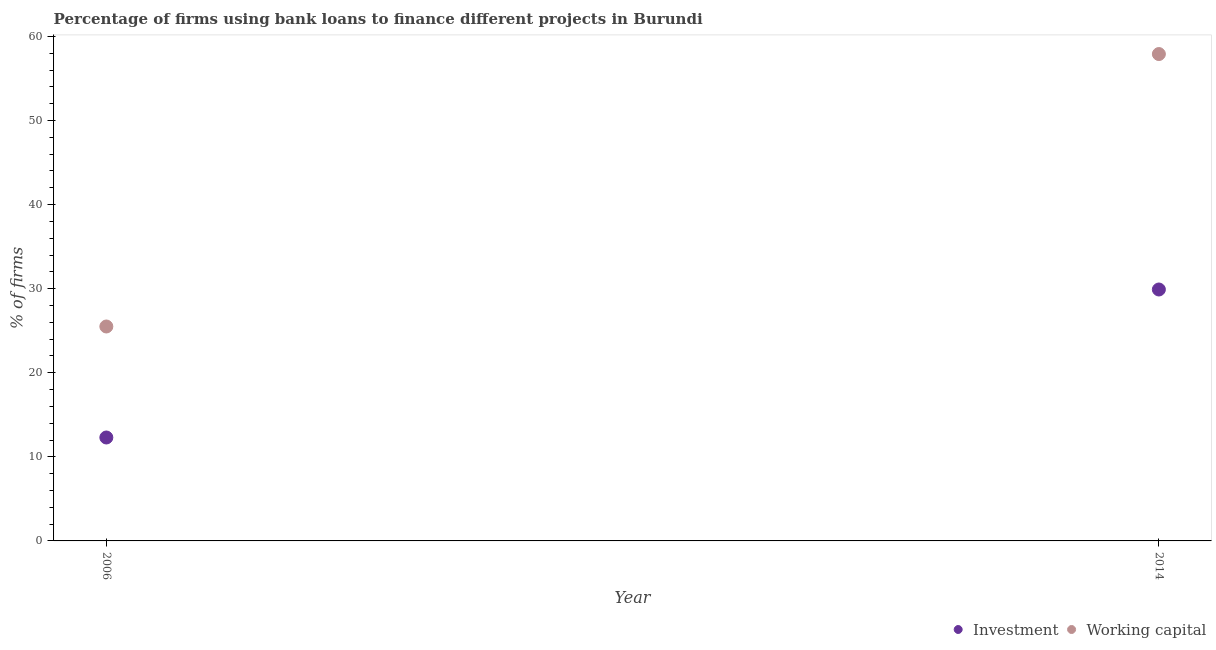How many different coloured dotlines are there?
Provide a succinct answer. 2. Across all years, what is the maximum percentage of firms using banks to finance investment?
Your answer should be very brief. 29.9. Across all years, what is the minimum percentage of firms using banks to finance investment?
Offer a very short reply. 12.3. In which year was the percentage of firms using banks to finance investment maximum?
Your answer should be compact. 2014. In which year was the percentage of firms using banks to finance working capital minimum?
Your answer should be very brief. 2006. What is the total percentage of firms using banks to finance investment in the graph?
Give a very brief answer. 42.2. What is the difference between the percentage of firms using banks to finance investment in 2006 and that in 2014?
Your response must be concise. -17.6. What is the difference between the percentage of firms using banks to finance working capital in 2006 and the percentage of firms using banks to finance investment in 2014?
Your answer should be compact. -4.4. What is the average percentage of firms using banks to finance investment per year?
Your answer should be very brief. 21.1. In the year 2014, what is the difference between the percentage of firms using banks to finance investment and percentage of firms using banks to finance working capital?
Offer a terse response. -28. In how many years, is the percentage of firms using banks to finance investment greater than 20 %?
Keep it short and to the point. 1. What is the ratio of the percentage of firms using banks to finance investment in 2006 to that in 2014?
Your answer should be very brief. 0.41. Is the percentage of firms using banks to finance investment in 2006 less than that in 2014?
Give a very brief answer. Yes. In how many years, is the percentage of firms using banks to finance working capital greater than the average percentage of firms using banks to finance working capital taken over all years?
Offer a very short reply. 1. Is the percentage of firms using banks to finance working capital strictly greater than the percentage of firms using banks to finance investment over the years?
Your answer should be compact. Yes. How many years are there in the graph?
Provide a succinct answer. 2. What is the difference between two consecutive major ticks on the Y-axis?
Your answer should be very brief. 10. What is the title of the graph?
Give a very brief answer. Percentage of firms using bank loans to finance different projects in Burundi. Does "Merchandise exports" appear as one of the legend labels in the graph?
Provide a succinct answer. No. What is the label or title of the X-axis?
Offer a very short reply. Year. What is the label or title of the Y-axis?
Provide a succinct answer. % of firms. What is the % of firms of Investment in 2006?
Your answer should be very brief. 12.3. What is the % of firms in Investment in 2014?
Your answer should be compact. 29.9. What is the % of firms of Working capital in 2014?
Provide a succinct answer. 57.9. Across all years, what is the maximum % of firms of Investment?
Give a very brief answer. 29.9. Across all years, what is the maximum % of firms in Working capital?
Offer a very short reply. 57.9. Across all years, what is the minimum % of firms in Investment?
Your answer should be compact. 12.3. What is the total % of firms of Investment in the graph?
Give a very brief answer. 42.2. What is the total % of firms of Working capital in the graph?
Provide a short and direct response. 83.4. What is the difference between the % of firms of Investment in 2006 and that in 2014?
Your answer should be compact. -17.6. What is the difference between the % of firms in Working capital in 2006 and that in 2014?
Ensure brevity in your answer.  -32.4. What is the difference between the % of firms of Investment in 2006 and the % of firms of Working capital in 2014?
Your answer should be compact. -45.6. What is the average % of firms in Investment per year?
Give a very brief answer. 21.1. What is the average % of firms of Working capital per year?
Your answer should be compact. 41.7. What is the ratio of the % of firms of Investment in 2006 to that in 2014?
Your answer should be compact. 0.41. What is the ratio of the % of firms of Working capital in 2006 to that in 2014?
Provide a succinct answer. 0.44. What is the difference between the highest and the second highest % of firms of Working capital?
Your response must be concise. 32.4. What is the difference between the highest and the lowest % of firms in Investment?
Your answer should be very brief. 17.6. What is the difference between the highest and the lowest % of firms in Working capital?
Keep it short and to the point. 32.4. 